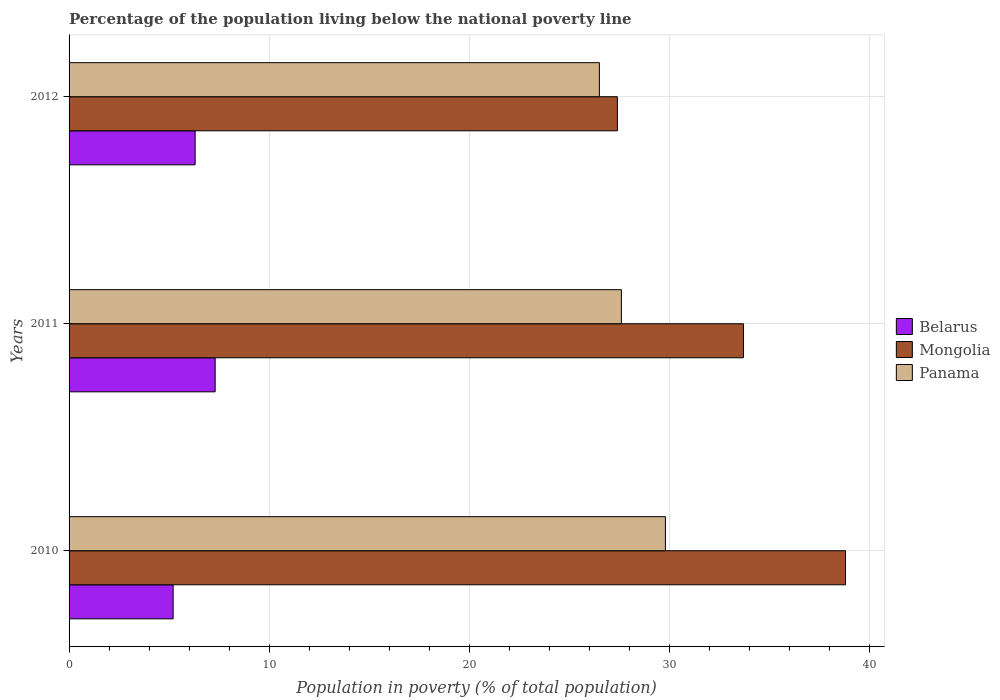How many groups of bars are there?
Your answer should be very brief. 3. Are the number of bars per tick equal to the number of legend labels?
Make the answer very short. Yes. Are the number of bars on each tick of the Y-axis equal?
Provide a succinct answer. Yes. How many bars are there on the 2nd tick from the top?
Your response must be concise. 3. In how many cases, is the number of bars for a given year not equal to the number of legend labels?
Give a very brief answer. 0. What is the percentage of the population living below the national poverty line in Mongolia in 2011?
Your answer should be compact. 33.7. Across all years, what is the maximum percentage of the population living below the national poverty line in Mongolia?
Keep it short and to the point. 38.8. Across all years, what is the minimum percentage of the population living below the national poverty line in Mongolia?
Provide a short and direct response. 27.4. In which year was the percentage of the population living below the national poverty line in Mongolia minimum?
Provide a succinct answer. 2012. What is the difference between the percentage of the population living below the national poverty line in Panama in 2011 and that in 2012?
Keep it short and to the point. 1.1. What is the difference between the percentage of the population living below the national poverty line in Panama in 2011 and the percentage of the population living below the national poverty line in Belarus in 2012?
Keep it short and to the point. 21.3. What is the average percentage of the population living below the national poverty line in Panama per year?
Provide a succinct answer. 27.97. In the year 2010, what is the difference between the percentage of the population living below the national poverty line in Mongolia and percentage of the population living below the national poverty line in Panama?
Offer a terse response. 9. In how many years, is the percentage of the population living below the national poverty line in Belarus greater than 10 %?
Offer a terse response. 0. What is the ratio of the percentage of the population living below the national poverty line in Mongolia in 2010 to that in 2011?
Your response must be concise. 1.15. What is the difference between the highest and the second highest percentage of the population living below the national poverty line in Mongolia?
Offer a very short reply. 5.1. What is the difference between the highest and the lowest percentage of the population living below the national poverty line in Belarus?
Your response must be concise. 2.1. In how many years, is the percentage of the population living below the national poverty line in Panama greater than the average percentage of the population living below the national poverty line in Panama taken over all years?
Keep it short and to the point. 1. What does the 3rd bar from the top in 2011 represents?
Offer a very short reply. Belarus. What does the 1st bar from the bottom in 2012 represents?
Make the answer very short. Belarus. Is it the case that in every year, the sum of the percentage of the population living below the national poverty line in Mongolia and percentage of the population living below the national poverty line in Belarus is greater than the percentage of the population living below the national poverty line in Panama?
Provide a short and direct response. Yes. What is the difference between two consecutive major ticks on the X-axis?
Make the answer very short. 10. Does the graph contain any zero values?
Provide a short and direct response. No. How are the legend labels stacked?
Give a very brief answer. Vertical. What is the title of the graph?
Your response must be concise. Percentage of the population living below the national poverty line. What is the label or title of the X-axis?
Make the answer very short. Population in poverty (% of total population). What is the Population in poverty (% of total population) of Belarus in 2010?
Ensure brevity in your answer.  5.2. What is the Population in poverty (% of total population) in Mongolia in 2010?
Your response must be concise. 38.8. What is the Population in poverty (% of total population) in Panama in 2010?
Provide a short and direct response. 29.8. What is the Population in poverty (% of total population) of Belarus in 2011?
Offer a terse response. 7.3. What is the Population in poverty (% of total population) in Mongolia in 2011?
Make the answer very short. 33.7. What is the Population in poverty (% of total population) in Panama in 2011?
Your answer should be compact. 27.6. What is the Population in poverty (% of total population) of Mongolia in 2012?
Keep it short and to the point. 27.4. What is the Population in poverty (% of total population) of Panama in 2012?
Your response must be concise. 26.5. Across all years, what is the maximum Population in poverty (% of total population) in Belarus?
Offer a terse response. 7.3. Across all years, what is the maximum Population in poverty (% of total population) in Mongolia?
Your answer should be compact. 38.8. Across all years, what is the maximum Population in poverty (% of total population) of Panama?
Offer a terse response. 29.8. Across all years, what is the minimum Population in poverty (% of total population) in Mongolia?
Provide a succinct answer. 27.4. What is the total Population in poverty (% of total population) in Mongolia in the graph?
Your response must be concise. 99.9. What is the total Population in poverty (% of total population) of Panama in the graph?
Offer a very short reply. 83.9. What is the difference between the Population in poverty (% of total population) of Belarus in 2010 and that in 2011?
Your response must be concise. -2.1. What is the difference between the Population in poverty (% of total population) in Mongolia in 2010 and that in 2011?
Give a very brief answer. 5.1. What is the difference between the Population in poverty (% of total population) of Panama in 2010 and that in 2011?
Offer a very short reply. 2.2. What is the difference between the Population in poverty (% of total population) of Mongolia in 2010 and that in 2012?
Make the answer very short. 11.4. What is the difference between the Population in poverty (% of total population) of Panama in 2010 and that in 2012?
Your response must be concise. 3.3. What is the difference between the Population in poverty (% of total population) of Belarus in 2011 and that in 2012?
Offer a very short reply. 1. What is the difference between the Population in poverty (% of total population) of Panama in 2011 and that in 2012?
Provide a short and direct response. 1.1. What is the difference between the Population in poverty (% of total population) in Belarus in 2010 and the Population in poverty (% of total population) in Mongolia in 2011?
Give a very brief answer. -28.5. What is the difference between the Population in poverty (% of total population) of Belarus in 2010 and the Population in poverty (% of total population) of Panama in 2011?
Offer a terse response. -22.4. What is the difference between the Population in poverty (% of total population) of Belarus in 2010 and the Population in poverty (% of total population) of Mongolia in 2012?
Make the answer very short. -22.2. What is the difference between the Population in poverty (% of total population) in Belarus in 2010 and the Population in poverty (% of total population) in Panama in 2012?
Provide a short and direct response. -21.3. What is the difference between the Population in poverty (% of total population) of Mongolia in 2010 and the Population in poverty (% of total population) of Panama in 2012?
Give a very brief answer. 12.3. What is the difference between the Population in poverty (% of total population) of Belarus in 2011 and the Population in poverty (% of total population) of Mongolia in 2012?
Your answer should be very brief. -20.1. What is the difference between the Population in poverty (% of total population) in Belarus in 2011 and the Population in poverty (% of total population) in Panama in 2012?
Your answer should be compact. -19.2. What is the average Population in poverty (% of total population) in Belarus per year?
Provide a short and direct response. 6.27. What is the average Population in poverty (% of total population) of Mongolia per year?
Offer a terse response. 33.3. What is the average Population in poverty (% of total population) of Panama per year?
Make the answer very short. 27.97. In the year 2010, what is the difference between the Population in poverty (% of total population) of Belarus and Population in poverty (% of total population) of Mongolia?
Provide a succinct answer. -33.6. In the year 2010, what is the difference between the Population in poverty (% of total population) in Belarus and Population in poverty (% of total population) in Panama?
Offer a very short reply. -24.6. In the year 2010, what is the difference between the Population in poverty (% of total population) of Mongolia and Population in poverty (% of total population) of Panama?
Ensure brevity in your answer.  9. In the year 2011, what is the difference between the Population in poverty (% of total population) of Belarus and Population in poverty (% of total population) of Mongolia?
Your response must be concise. -26.4. In the year 2011, what is the difference between the Population in poverty (% of total population) in Belarus and Population in poverty (% of total population) in Panama?
Provide a short and direct response. -20.3. In the year 2011, what is the difference between the Population in poverty (% of total population) in Mongolia and Population in poverty (% of total population) in Panama?
Ensure brevity in your answer.  6.1. In the year 2012, what is the difference between the Population in poverty (% of total population) of Belarus and Population in poverty (% of total population) of Mongolia?
Make the answer very short. -21.1. In the year 2012, what is the difference between the Population in poverty (% of total population) in Belarus and Population in poverty (% of total population) in Panama?
Your answer should be compact. -20.2. What is the ratio of the Population in poverty (% of total population) of Belarus in 2010 to that in 2011?
Your answer should be compact. 0.71. What is the ratio of the Population in poverty (% of total population) in Mongolia in 2010 to that in 2011?
Provide a short and direct response. 1.15. What is the ratio of the Population in poverty (% of total population) of Panama in 2010 to that in 2011?
Ensure brevity in your answer.  1.08. What is the ratio of the Population in poverty (% of total population) in Belarus in 2010 to that in 2012?
Provide a short and direct response. 0.83. What is the ratio of the Population in poverty (% of total population) in Mongolia in 2010 to that in 2012?
Your answer should be very brief. 1.42. What is the ratio of the Population in poverty (% of total population) in Panama in 2010 to that in 2012?
Offer a terse response. 1.12. What is the ratio of the Population in poverty (% of total population) of Belarus in 2011 to that in 2012?
Give a very brief answer. 1.16. What is the ratio of the Population in poverty (% of total population) of Mongolia in 2011 to that in 2012?
Keep it short and to the point. 1.23. What is the ratio of the Population in poverty (% of total population) of Panama in 2011 to that in 2012?
Give a very brief answer. 1.04. What is the difference between the highest and the second highest Population in poverty (% of total population) of Belarus?
Your response must be concise. 1. What is the difference between the highest and the second highest Population in poverty (% of total population) in Mongolia?
Your response must be concise. 5.1. What is the difference between the highest and the second highest Population in poverty (% of total population) in Panama?
Your response must be concise. 2.2. What is the difference between the highest and the lowest Population in poverty (% of total population) in Panama?
Your answer should be compact. 3.3. 